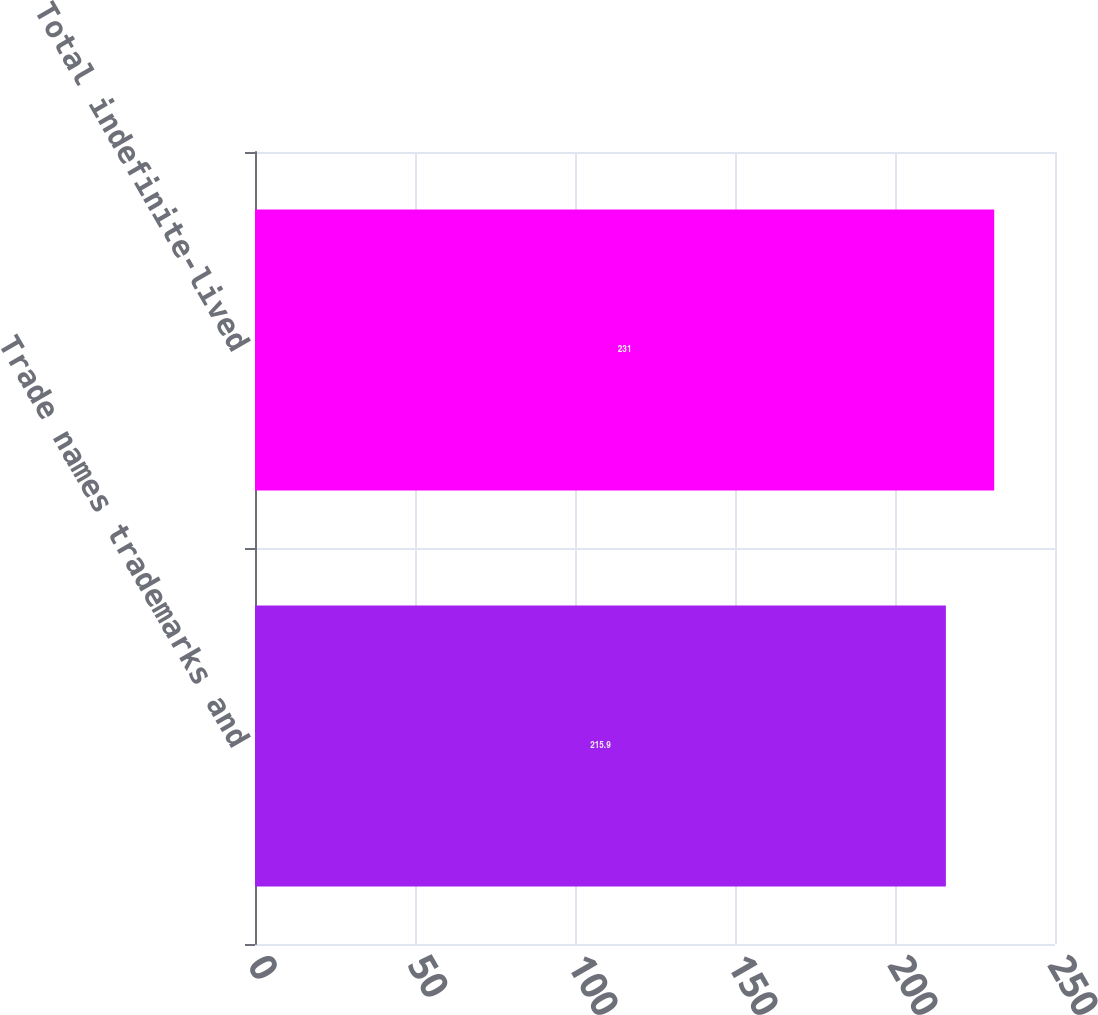Convert chart. <chart><loc_0><loc_0><loc_500><loc_500><bar_chart><fcel>Trade names trademarks and<fcel>Total indefinite-lived<nl><fcel>215.9<fcel>231<nl></chart> 